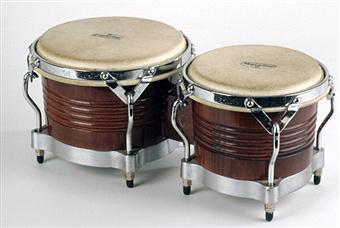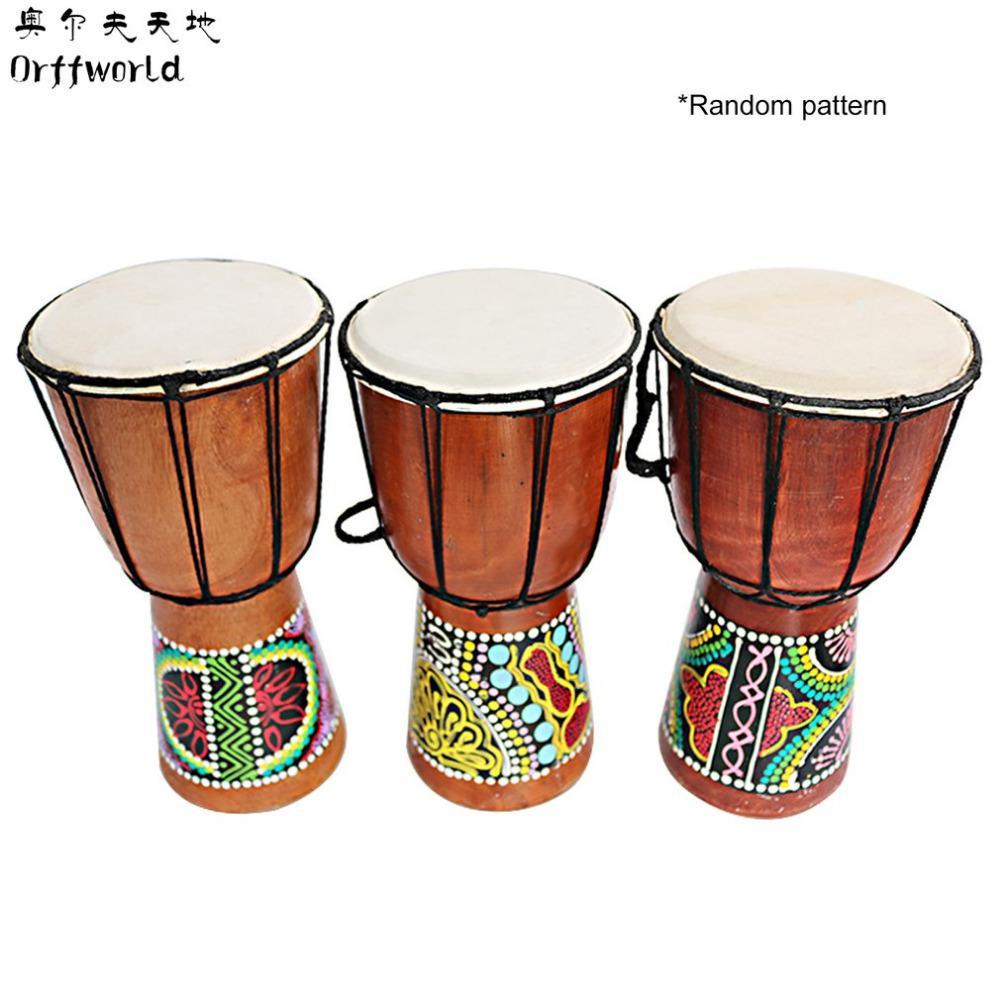The first image is the image on the left, the second image is the image on the right. For the images shown, is this caption "One image shows two basket-shaped drums connected side-by-side,and the other image shows a more slender chalice-shaped drum style, with a decorated base and rope netting around the sides." true? Answer yes or no. Yes. The first image is the image on the left, the second image is the image on the right. Examine the images to the left and right. Is the description "There are twice as many drums in the image on the right." accurate? Answer yes or no. No. 